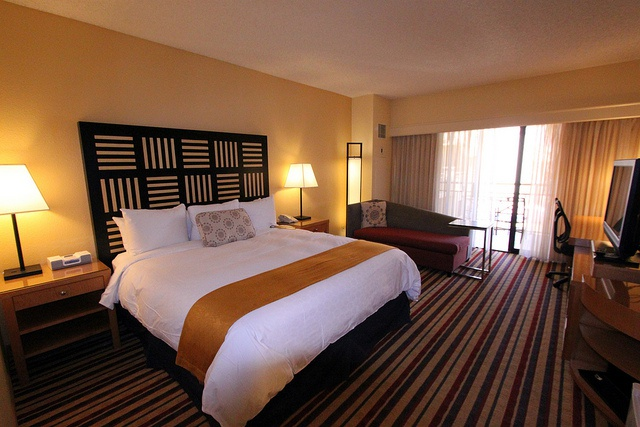Describe the objects in this image and their specific colors. I can see bed in brown, darkgray, black, and gray tones, couch in brown, black, and maroon tones, tv in brown, black, and maroon tones, chair in brown, black, and maroon tones, and clock in brown, gray, tan, and maroon tones in this image. 